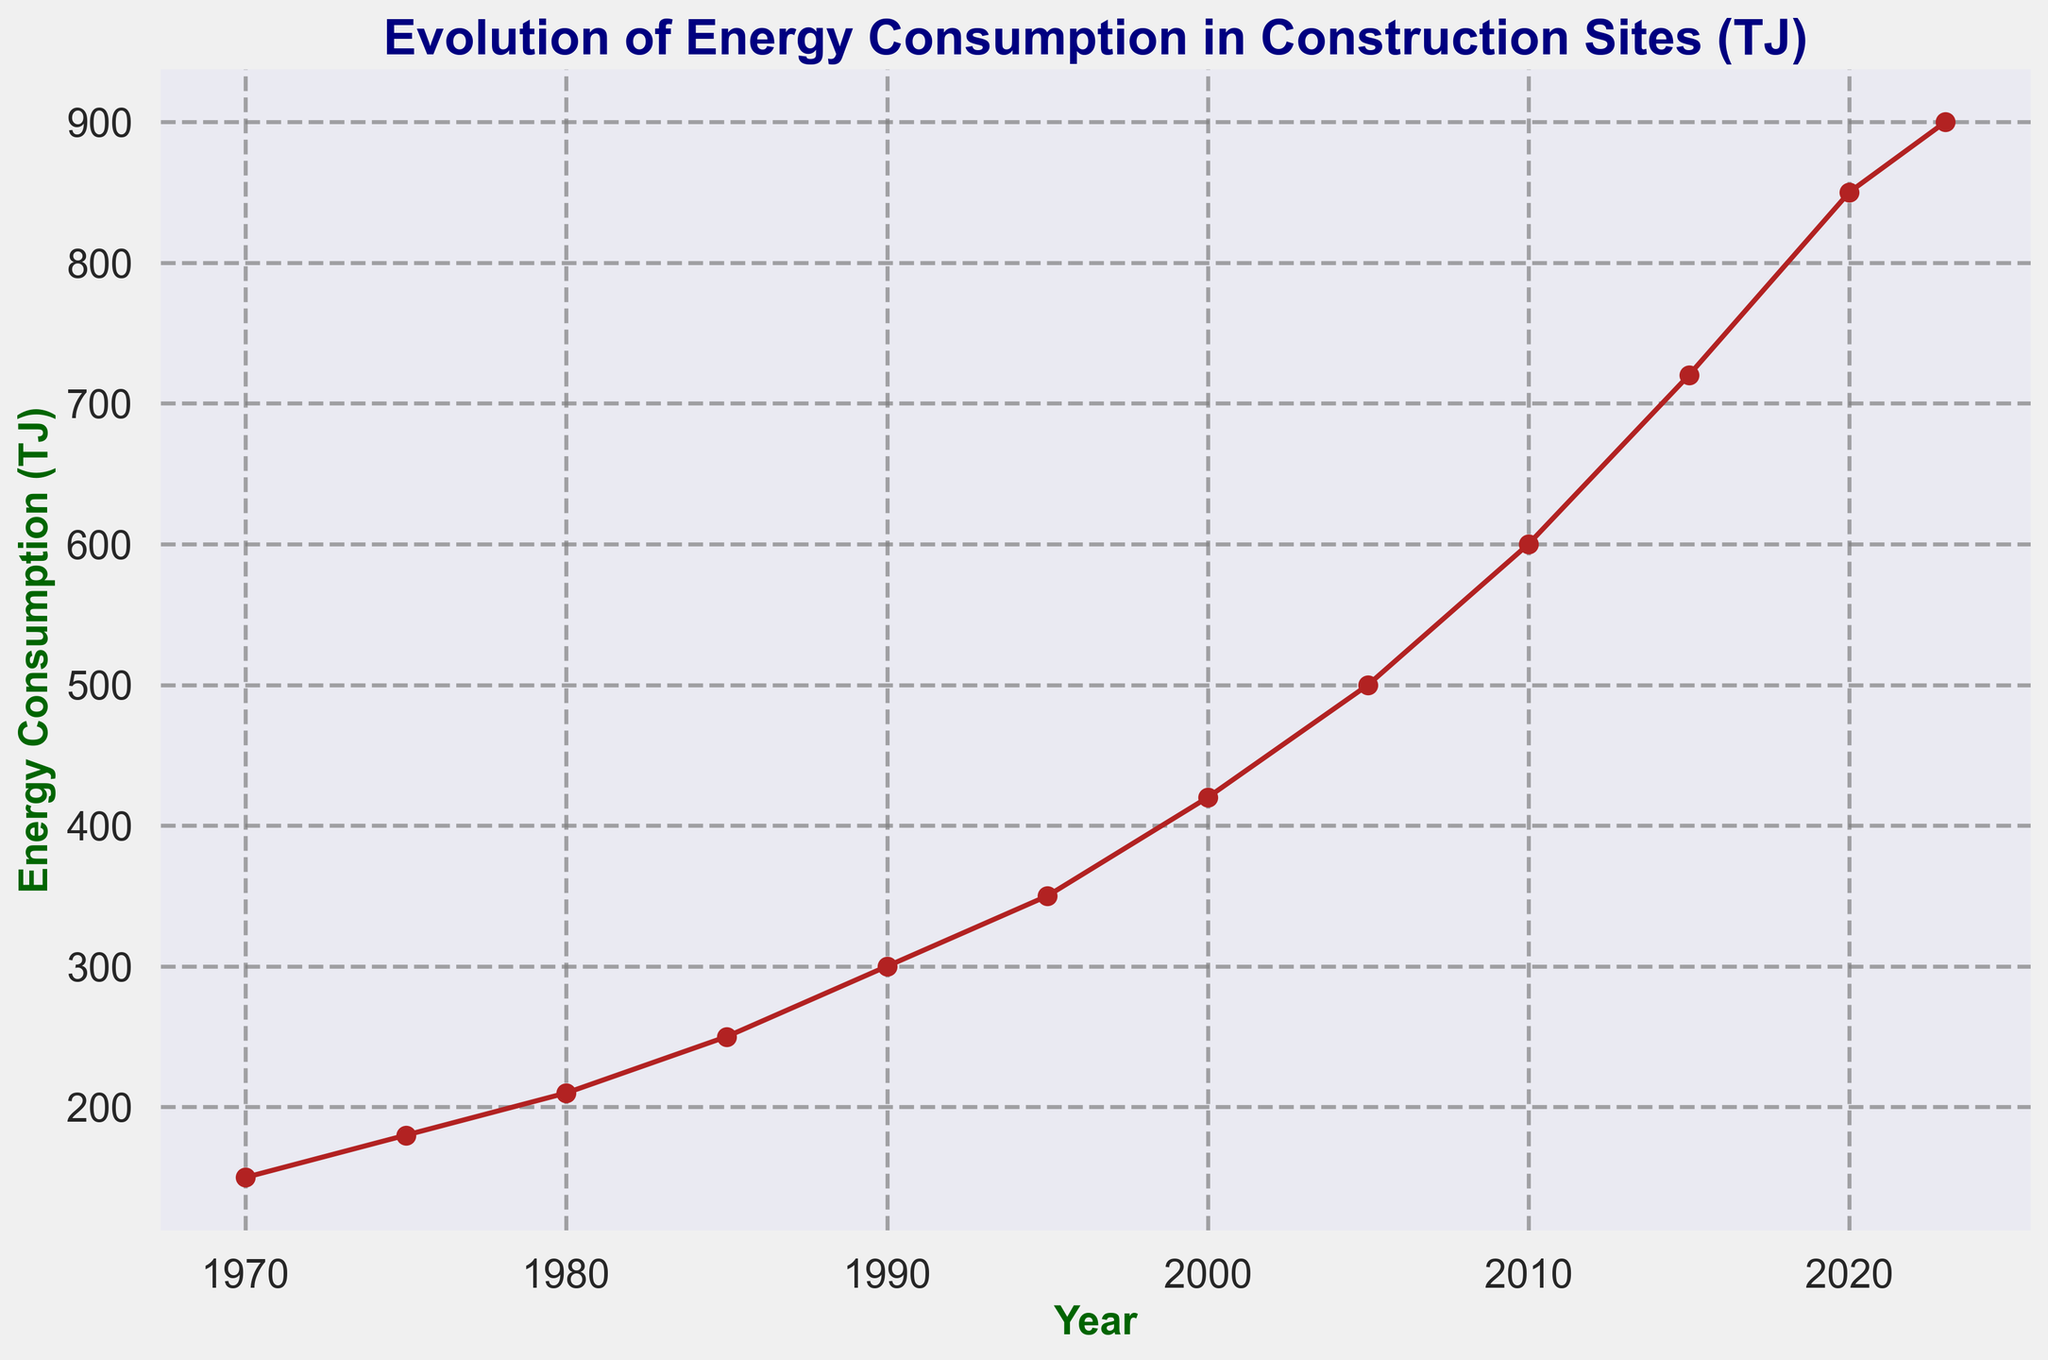What is the first year shown in the figure? The x-axis represents the years, and the line chart starts at the leftmost point labeled 1970.
Answer: 1970 By how much did the energy consumption increase from 1970 to 2023? To find the increase, subtract the energy consumption in 1970 (150 TJ) from the energy consumption in 2023 (900 TJ). The increase is 900 - 150.
Answer: 750 TJ What is the average energy consumption between 1980 and 2000? The years in the range 1980 to 2000 include 1980 (210 TJ), 1985 (250 TJ), 1990 (300 TJ), 1995 (350 TJ), and 2000 (420 TJ). The average is calculated as (210 + 250 + 300 + 350 + 420) / 5.
Answer: 306 TJ How does the energy consumption in 2010 compare to that in 1990? The energy consumption in 2010 is 600 TJ, and in 1990 it is 300 TJ. Comparing these values, we observe that the energy consumption in 2010 is double that in 1990.
Answer: Double Which year shows the highest energy consumption according to the plot? The highest point on the plotted line indicates the year 2023 with energy consumption of 900 TJ.
Answer: 2023 Identify a decade with a significant increase in energy consumption and calculate the difference. From 2000 to 2010, energy consumption increased significantly from 420 TJ to 600 TJ. The difference can be calculated as 600 - 420.
Answer: 180 TJ What visual attribute distinguishes the data points on the line chart? The data points on the line chart are marked with red-colored circular markers.
Answer: Red-colored circular markers Describe the trend of energy consumption from 1970 to 2023. The line graph shows an overall increasing trend in energy consumption from the lowest value of 150 TJ in 1970 to the highest value of 900 TJ in 2023, with more significant increases in the later decades.
Answer: Increasing trend What is the approximate rate of energy consumption growth per year between 2015 and 2020? Compute the growth by taking the consumption difference between 2020 and 2015 (850 - 720) and then divide by the number of years (5). The calculation is (850 - 720) / 5.
Answer: 26 TJ per year 